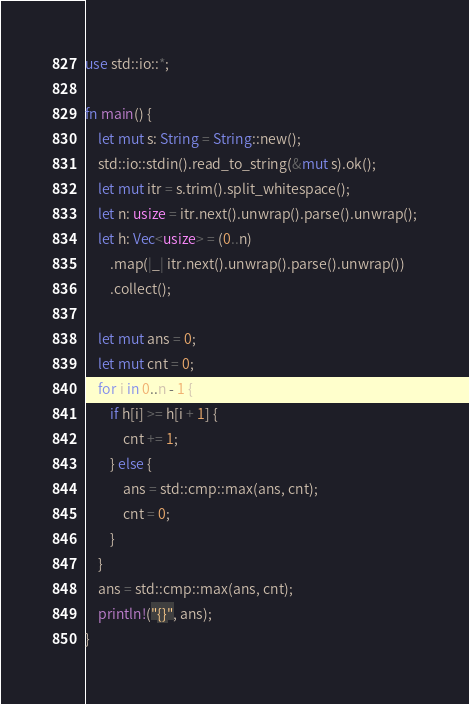<code> <loc_0><loc_0><loc_500><loc_500><_Rust_>use std::io::*;

fn main() {
    let mut s: String = String::new();
    std::io::stdin().read_to_string(&mut s).ok();
    let mut itr = s.trim().split_whitespace();
    let n: usize = itr.next().unwrap().parse().unwrap();
    let h: Vec<usize> = (0..n)
        .map(|_| itr.next().unwrap().parse().unwrap())
        .collect();

    let mut ans = 0;
    let mut cnt = 0;
    for i in 0..n - 1 {
        if h[i] >= h[i + 1] {
            cnt += 1;
        } else {
            ans = std::cmp::max(ans, cnt);
            cnt = 0;
        }
    }
    ans = std::cmp::max(ans, cnt);
    println!("{}", ans);
}
</code> 